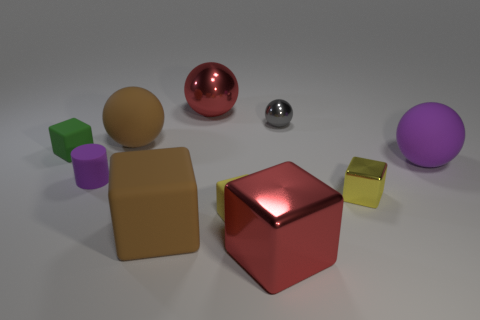Subtract all brown balls. How many balls are left? 3 Subtract all yellow cylinders. How many yellow cubes are left? 2 Subtract 3 blocks. How many blocks are left? 2 Subtract all red cubes. How many cubes are left? 4 Subtract all spheres. How many objects are left? 6 Subtract all gray metal balls. Subtract all tiny green matte objects. How many objects are left? 8 Add 4 purple spheres. How many purple spheres are left? 5 Add 4 tiny metallic cubes. How many tiny metallic cubes exist? 5 Subtract 1 gray spheres. How many objects are left? 9 Subtract all red cubes. Subtract all cyan spheres. How many cubes are left? 4 